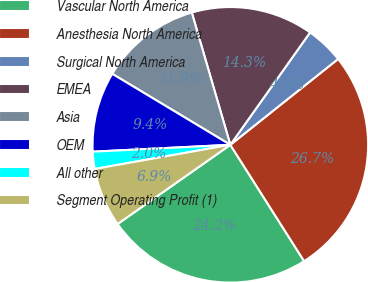<chart> <loc_0><loc_0><loc_500><loc_500><pie_chart><fcel>Vascular North America<fcel>Anesthesia North America<fcel>Surgical North America<fcel>EMEA<fcel>Asia<fcel>OEM<fcel>All other<fcel>Segment Operating Profit (1)<nl><fcel>24.25%<fcel>26.71%<fcel>4.47%<fcel>14.34%<fcel>11.87%<fcel>9.41%<fcel>2.01%<fcel>6.94%<nl></chart> 